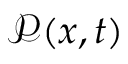Convert formula to latex. <formula><loc_0><loc_0><loc_500><loc_500>{ \mathcal { P } } ( x , t )</formula> 